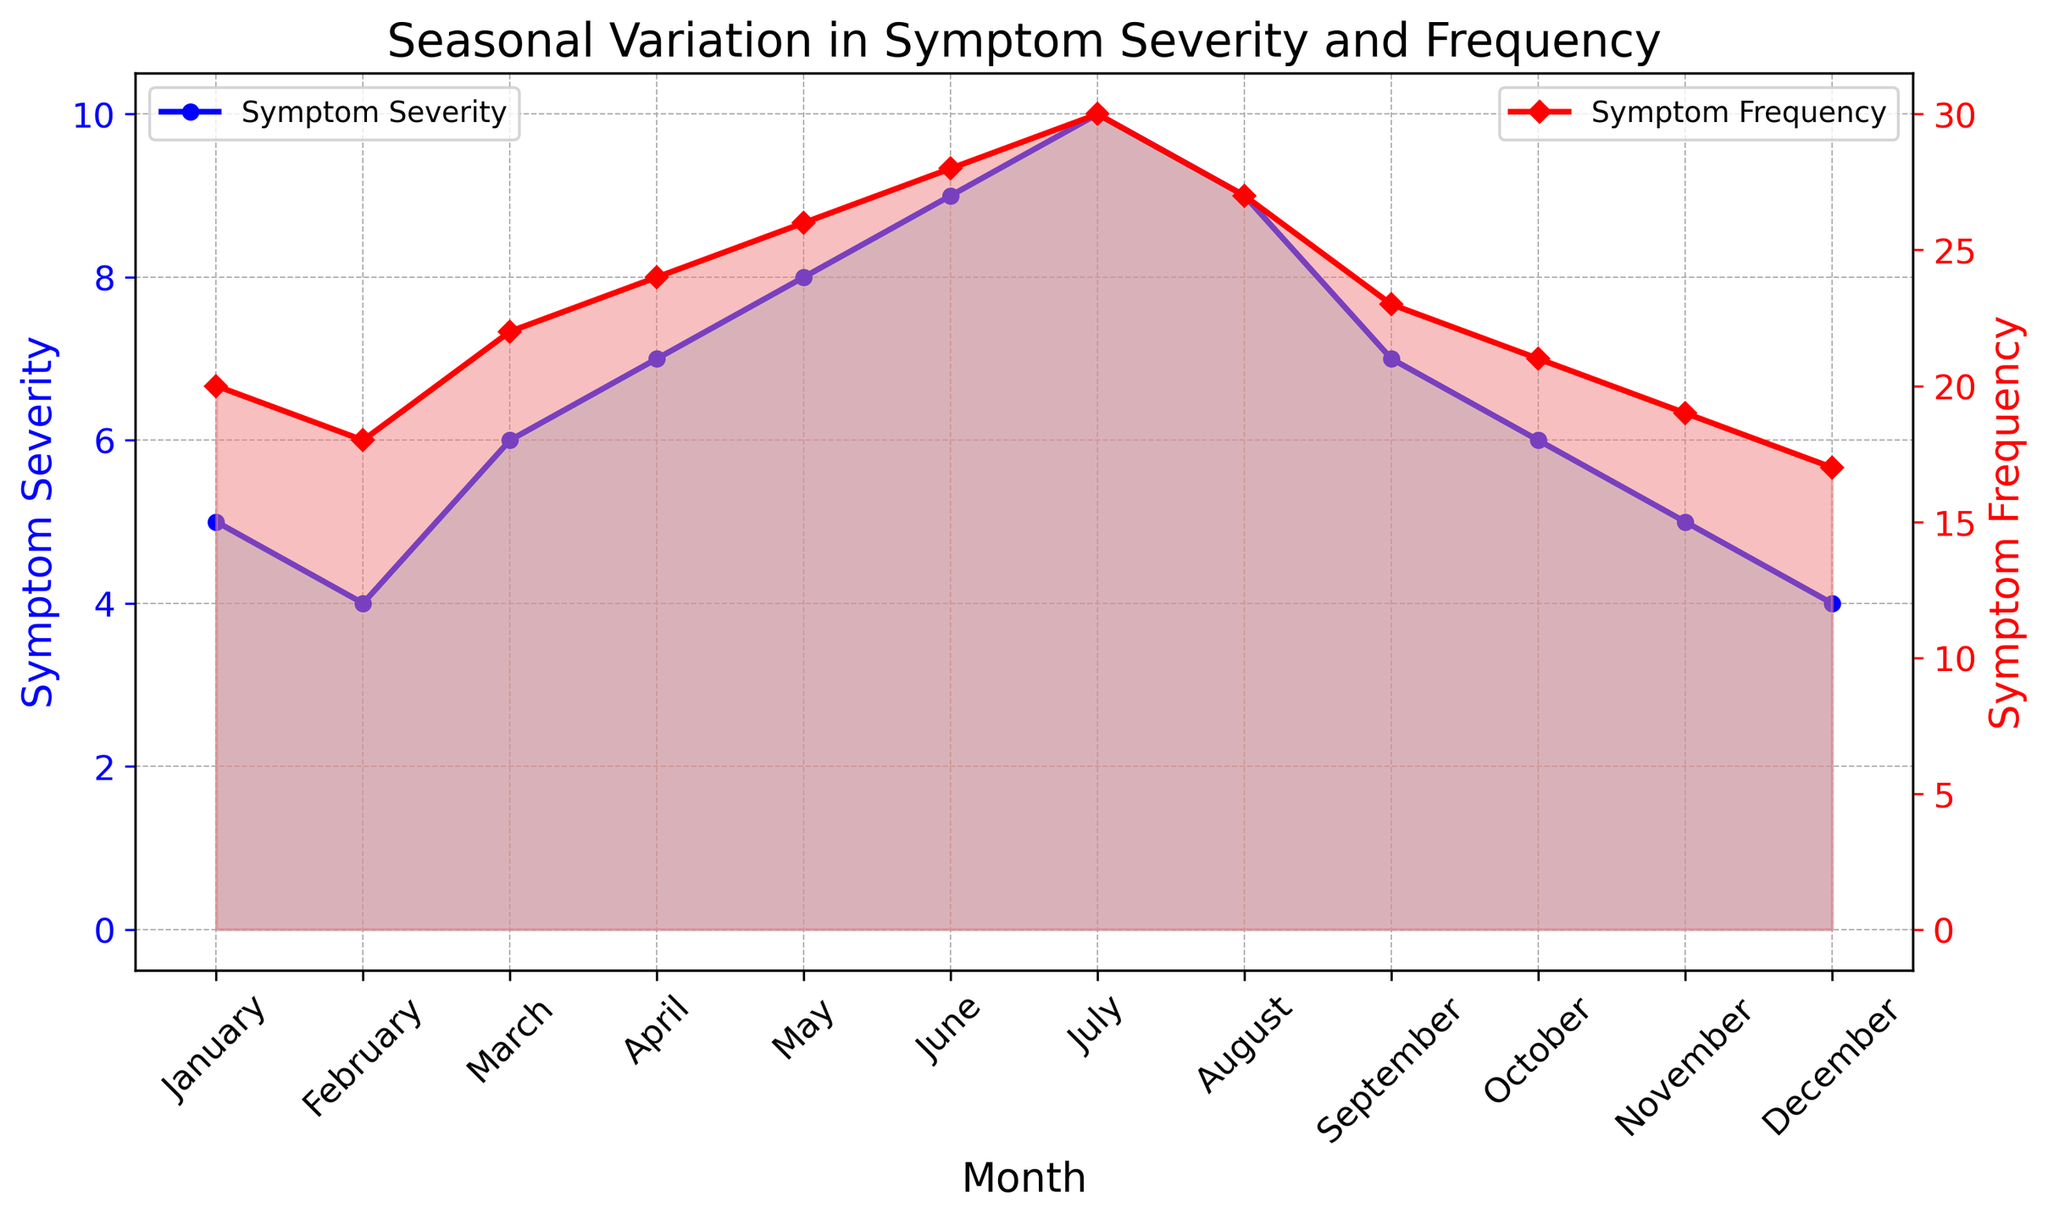Which month has the highest symptom severity? The plot shows symptom severity for each month, marked in a blue fill. The highest peak in the blue area is in July.
Answer: July During which month is symptom frequency the lowest? The plot shows symptom frequency for each month, marked in a red fill. The lowest point in the red area is in December.
Answer: December Compare the symptom severity in January and June. Which is higher? By looking at the blue areas in January and June, it is apparent that June has a higher symptom severity than January.
Answer: June Are there any months where symptom severity and frequency are equal? Reviewing both lines, there is no month where both the symptom severity and frequency values match exactly.
Answer: No How does symptom frequency change from February to March? The red plot shows symptom frequency. In February, it's 18, and in March, it increases to 22. Therefore, symptom frequency increases.
Answer: Increases Calculate the average symptom severity for the first half of the year (January to June). The symptom severities from January to June are 5, 4, 6, 7, 8, and 9. Summing these: 5 + 4 + 6 + 7 + 8 + 9 = 39. Dividing by 6 months gives an average of 39 / 6 = 6.5.
Answer: 6.5 Compare the trend of symptom severity and frequency from April to August. Between April and August, both severity and frequency increase, peak around July, and then decrease slightly in August. This indicates a similar trend.
Answer: Similar trend Identify which month(s) show a decrease in symptom frequency compared to the previous month. By observing the red line, symptom frequency decreases in August compared to July and in December compared to November.
Answer: August, December Which month has the highest divergence between symptom severity and frequency? The highest divergence occurs in July where symptom severity is 10 and frequency is 30, a divergence of 20.
Answer: July What is the sum of symptom severity and frequency in May? In May, symptom severity is 8 and frequency is 26. Their sum is 8 + 26 = 34.
Answer: 34 